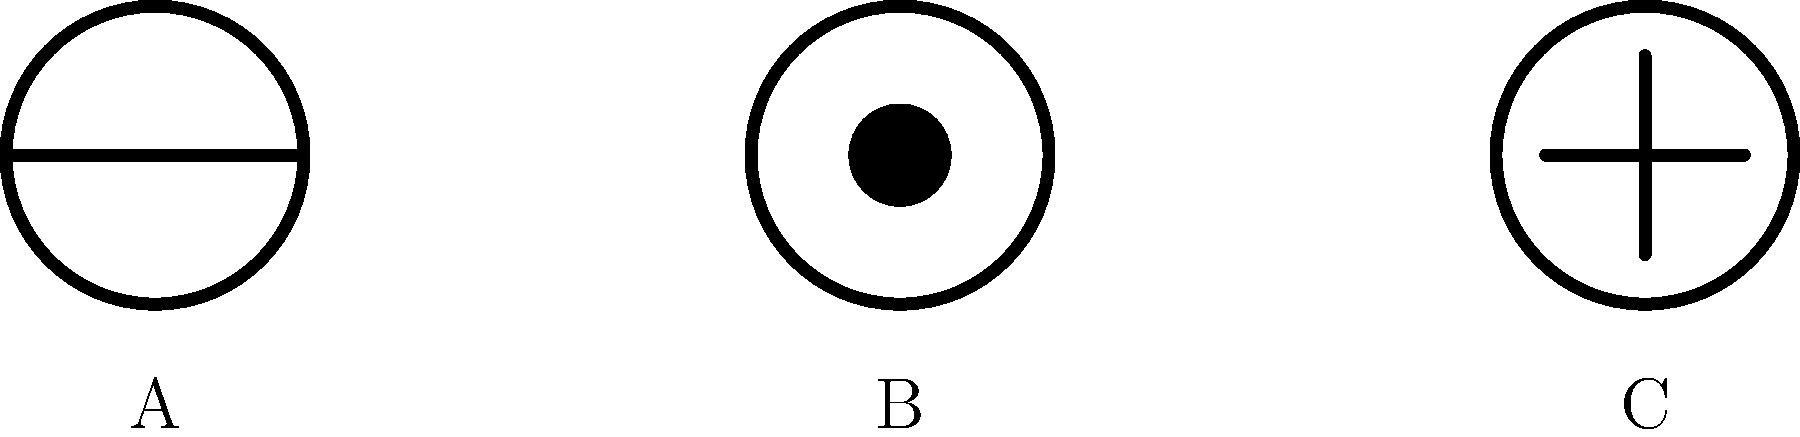Identify which insignia represents a US Navy Lieutenant among the given military rank symbols. To identify the US Navy Lieutenant insignia, let's analyze each symbol:

1. Symbol A:
   - Circular outline with two bars crossing the center
   - This represents a US Army Captain

2. Symbol B:
   - Circular outline with a solid black circle in the center
   - This represents a US Navy Lieutenant

3. Symbol C:
   - Circular outline with a cross in the center
   - This represents a US Air Force Captain

The US Navy uses a system of rings and filled circles for officer ranks. A single filled circle within a ring is the specific insignia for a Lieutenant in the US Navy.
Answer: B 